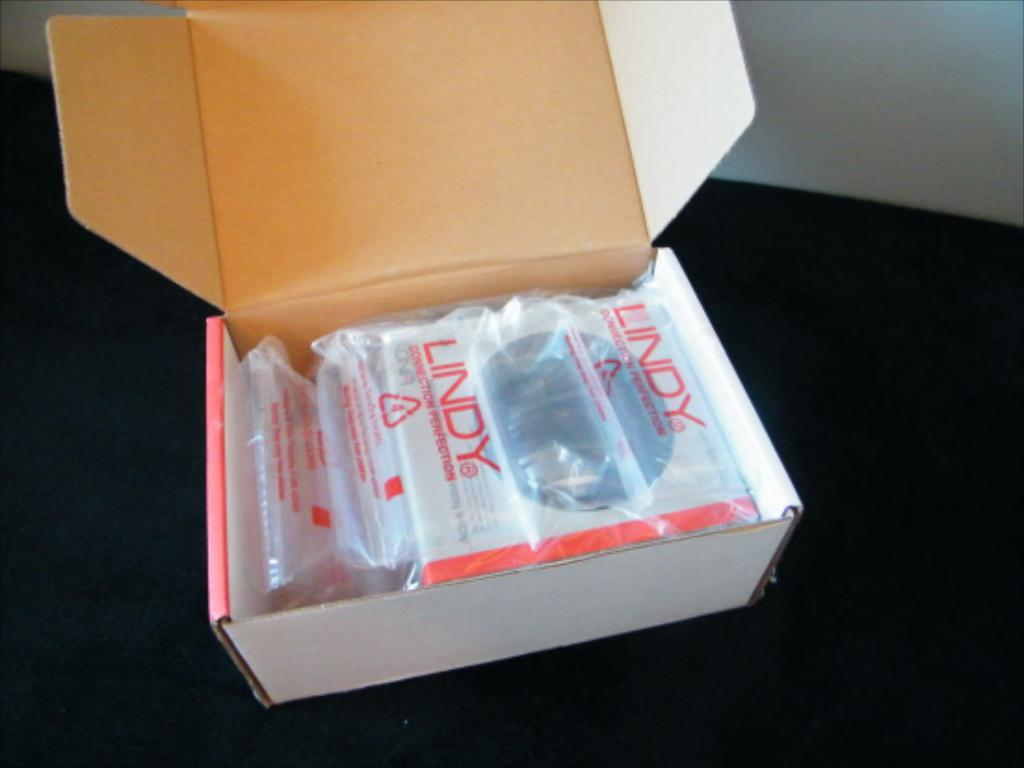<image>
Give a short and clear explanation of the subsequent image. A white box with a plastic wrapper that says Lindy. 